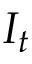Convert formula to latex. <formula><loc_0><loc_0><loc_500><loc_500>I _ { t }</formula> 